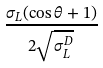Convert formula to latex. <formula><loc_0><loc_0><loc_500><loc_500>\frac { \sigma _ { L } ( \cos \theta + 1 ) } { 2 \sqrt { \sigma _ { L } ^ { D } } }</formula> 